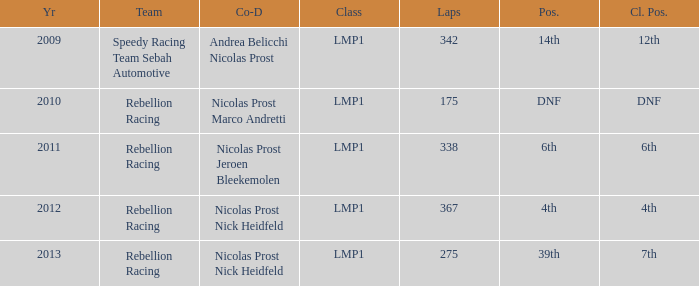What is Class Pos., when Year is before 2013, and when Laps is greater than 175? 12th, 6th, 4th. 